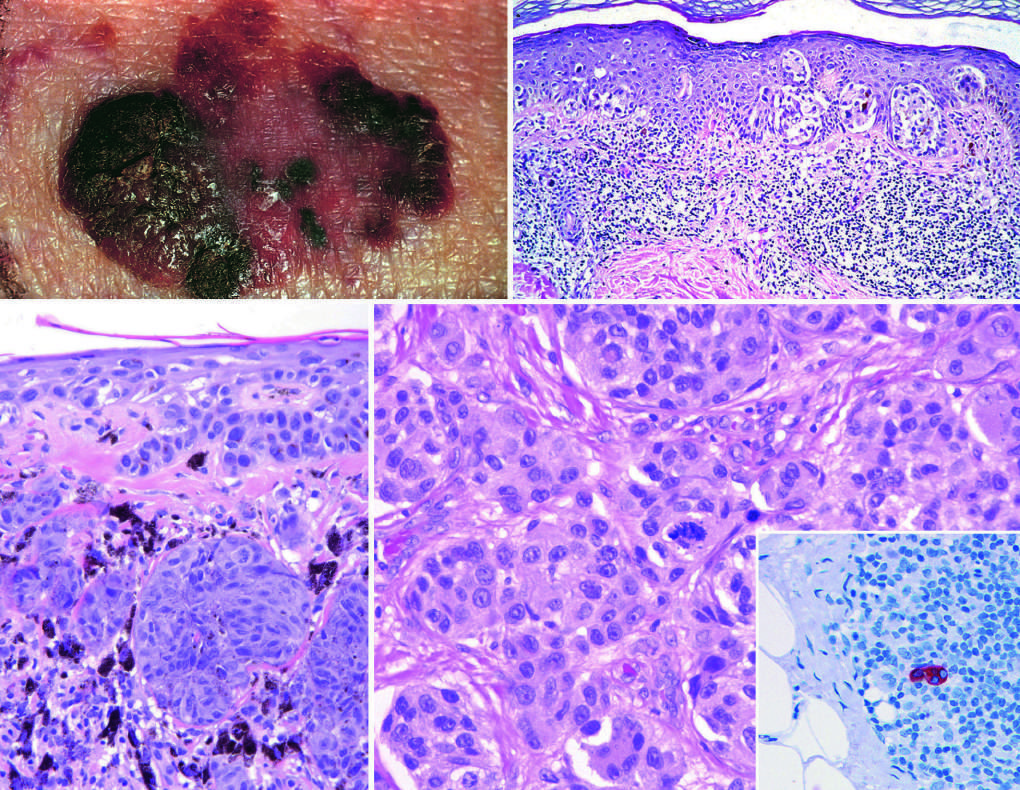where is the atypical mitotic figure in the field?
Answer the question using a single word or phrase. In the center 